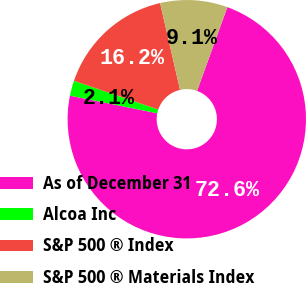Convert chart. <chart><loc_0><loc_0><loc_500><loc_500><pie_chart><fcel>As of December 31<fcel>Alcoa Inc<fcel>S&P 500 ® Index<fcel>S&P 500 ® Materials Index<nl><fcel>72.65%<fcel>2.06%<fcel>16.18%<fcel>9.12%<nl></chart> 